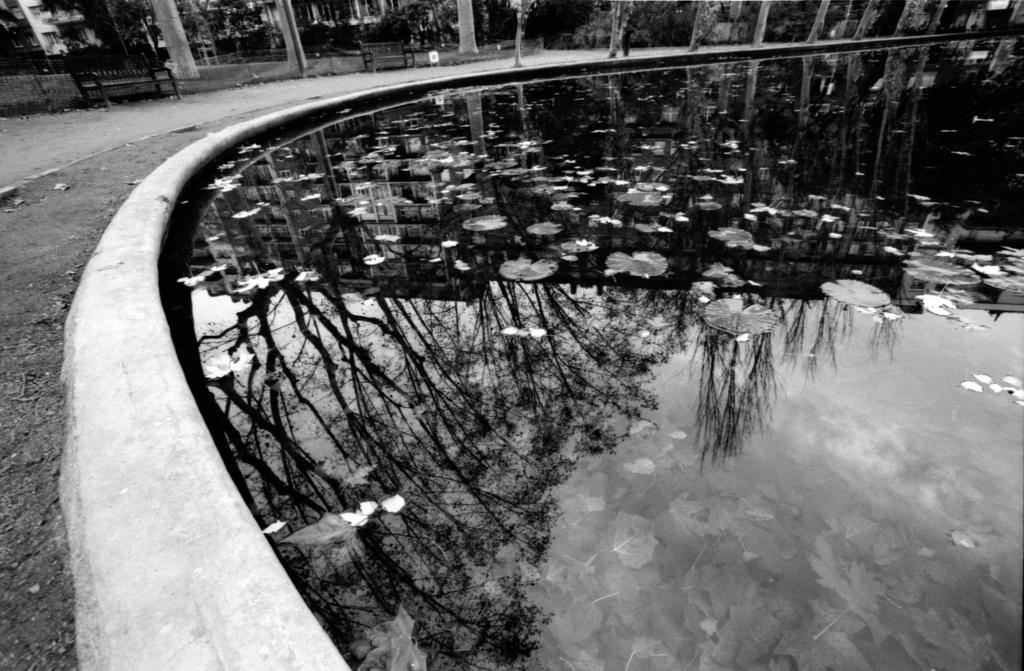What is the color scheme of the image? The image is black and white. What natural element can be seen in the image? There is water visible in the image. What type of plant life is present in the image? There are flowers, leaves, and trees visible in the image. What type of seating is available in the image? There are benches in the image. What type of barrier is present in the image? Fencing is present in the image. What type of ground cover is visible in the image? Grass is visible in the image. What type of man-made structures are visible in the image? There are buildings in the image. What type of metal is visible in the stomach of the person in the image? There is no person present in the image, and therefore no stomach or metal can be observed. 